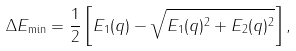Convert formula to latex. <formula><loc_0><loc_0><loc_500><loc_500>\Delta E _ { \min } = \frac { 1 } { 2 } \left [ E _ { 1 } ( q ) - \sqrt { E _ { 1 } ( q ) ^ { 2 } + E _ { 2 } ( q ) ^ { 2 } } \right ] ,</formula> 